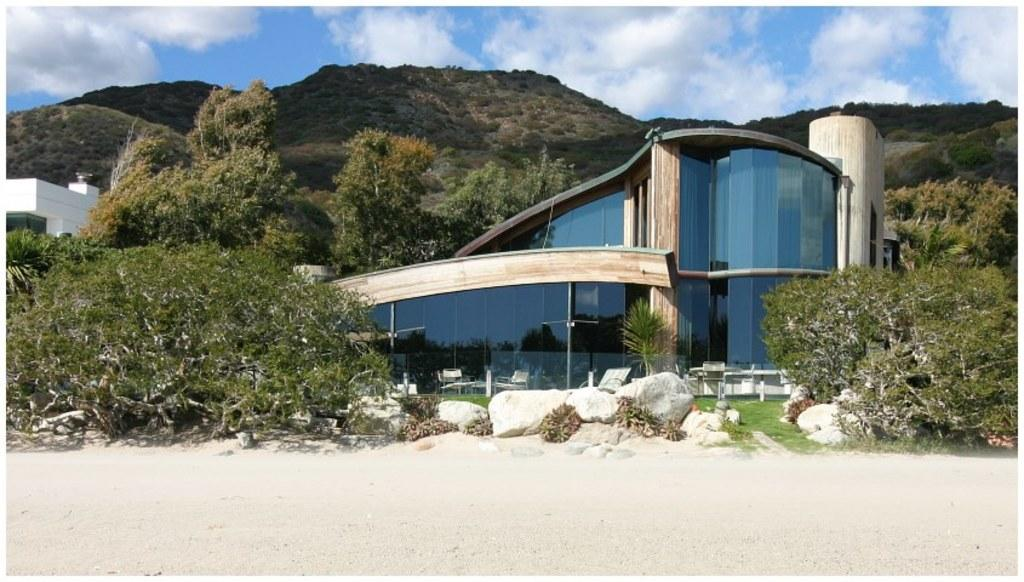What type of structures can be seen in the image? There are buildings in the image. What natural elements are present in the image? There are trees, plants, hills, and rocks in the image. What type of seating is visible in the image? There are chairs in the image. What can be seen in the background of the image? The sky is visible in the background of the image. What type of yarn is being used to create the nerve in the image? There is no yarn or nerve present in the image. What type of chairs are depicted in the image? The provided facts do not specify the type of chairs in the image, only that there are chairs present. 